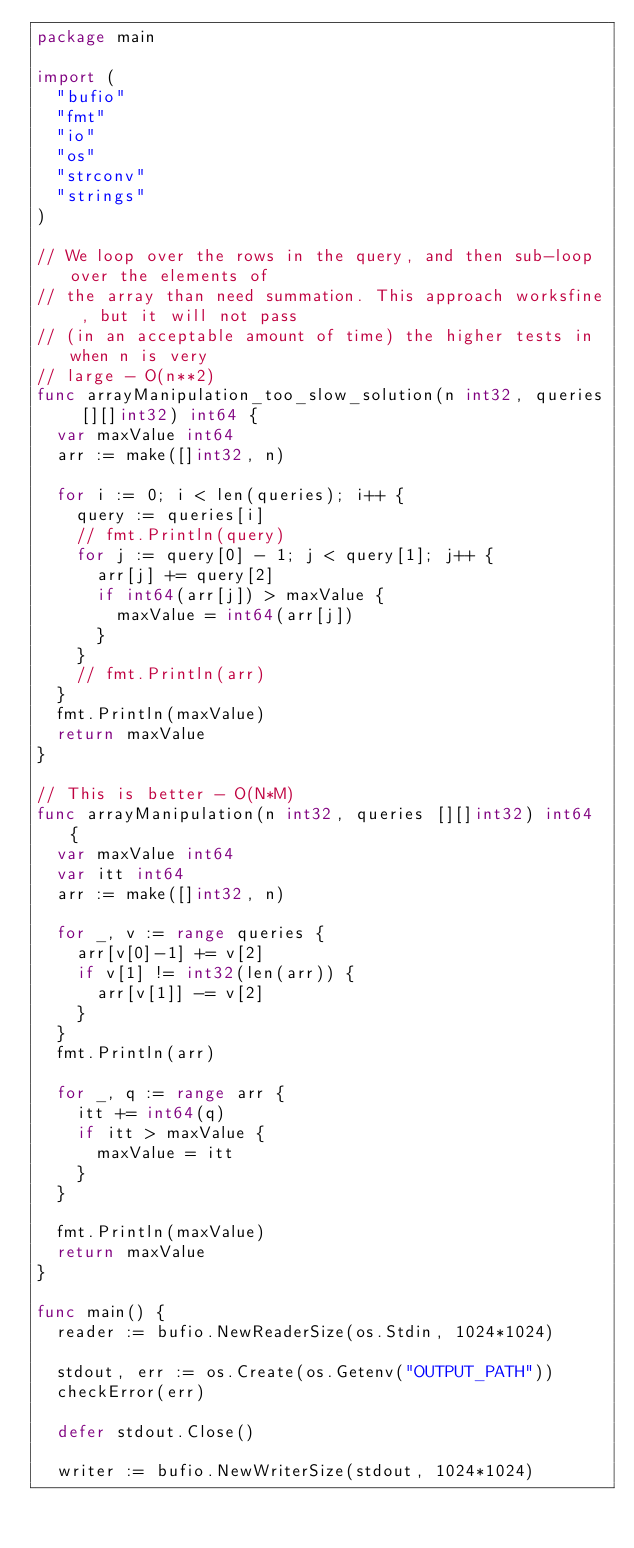<code> <loc_0><loc_0><loc_500><loc_500><_Go_>package main

import (
	"bufio"
	"fmt"
	"io"
	"os"
	"strconv"
	"strings"
)

// We loop over the rows in the query, and then sub-loop over the elements of
// the array than need summation. This approach worksfine , but it will not pass
// (in an acceptable amount of time) the higher tests in when n is very
// large - O(n**2)
func arrayManipulation_too_slow_solution(n int32, queries [][]int32) int64 {
	var maxValue int64
	arr := make([]int32, n)

	for i := 0; i < len(queries); i++ {
		query := queries[i]
		// fmt.Println(query)
		for j := query[0] - 1; j < query[1]; j++ {
			arr[j] += query[2]
			if int64(arr[j]) > maxValue {
				maxValue = int64(arr[j])
			}
		}
		// fmt.Println(arr)
	}
	fmt.Println(maxValue)
	return maxValue
}

// This is better - O(N*M)
func arrayManipulation(n int32, queries [][]int32) int64 {
	var maxValue int64
	var itt int64
	arr := make([]int32, n)

	for _, v := range queries {
		arr[v[0]-1] += v[2]
		if v[1] != int32(len(arr)) {
			arr[v[1]] -= v[2]
		}
	}
	fmt.Println(arr)

	for _, q := range arr {
		itt += int64(q)
		if itt > maxValue {
			maxValue = itt
		}
	}

	fmt.Println(maxValue)
	return maxValue
}

func main() {
	reader := bufio.NewReaderSize(os.Stdin, 1024*1024)

	stdout, err := os.Create(os.Getenv("OUTPUT_PATH"))
	checkError(err)

	defer stdout.Close()

	writer := bufio.NewWriterSize(stdout, 1024*1024)
</code> 